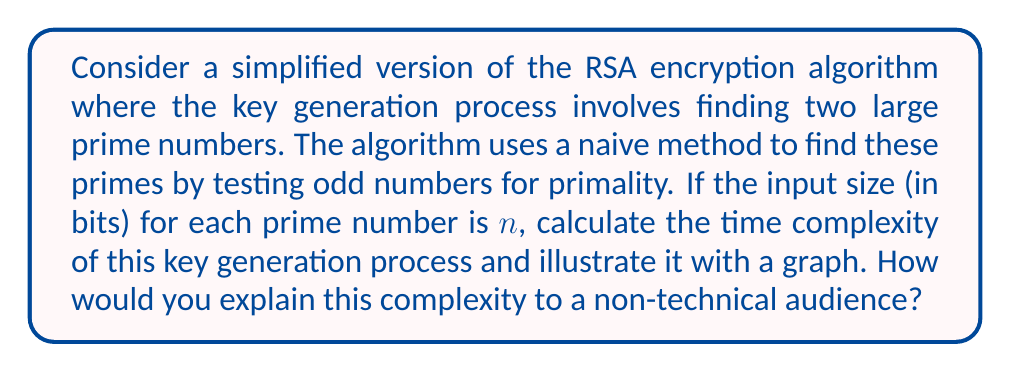What is the answer to this math problem? Let's break this down step-by-step:

1) In RSA, we need to find two large prime numbers. Let's consider finding one prime number first.

2) The input size is $n$ bits, which means we're looking for a prime number up to $2^n$.

3) The naive method checks odd numbers for primality. So, we're checking approximately $2^{n-1}$ numbers.

4) For each number, we need to check if it's divisible by any number up to its square root. The square root of $2^n$ is $2^{n/2}$.

5) This means for each number, we're doing about $2^{n/2}$ operations.

6) Combining steps 3 and 5, the total number of operations is approximately:

   $$ 2^{n-1} \cdot 2^{n/2} = 2^{n-1+n/2} = 2^{3n/2-1} $$

7) In Big O notation, we drop constants, so the time complexity is $O(2^{3n/2})$.

8) We need to do this twice (for two prime numbers), but in Big O notation, we also drop coefficients, so the final complexity remains $O(2^{3n/2})$.

To illustrate this with a graph:

[asy]
import graph;
size(200,150);
real f(real x) {return 2^(1.5*x);}
xaxis("Input size (n)",0,10,Arrow);
yaxis("Time",0,500,Arrow);
draw(graph(f,0,8));
label("$O(2^{3n/2})$",(6,400),E);
[/asy]

To explain this to a non-technical audience:

Imagine you're trying to find a specific book in a library that keeps doubling in size. As the library gets bigger, it takes more than twice as long to find the book. This is because not only do you have more books to check, but each book is also getting thicker, making it take longer to flip through. Similarly, as we increase the size of the numbers we're working with in our encryption, the time it takes grows very quickly - much faster than just doubling.
Answer: $O(2^{3n/2})$ 